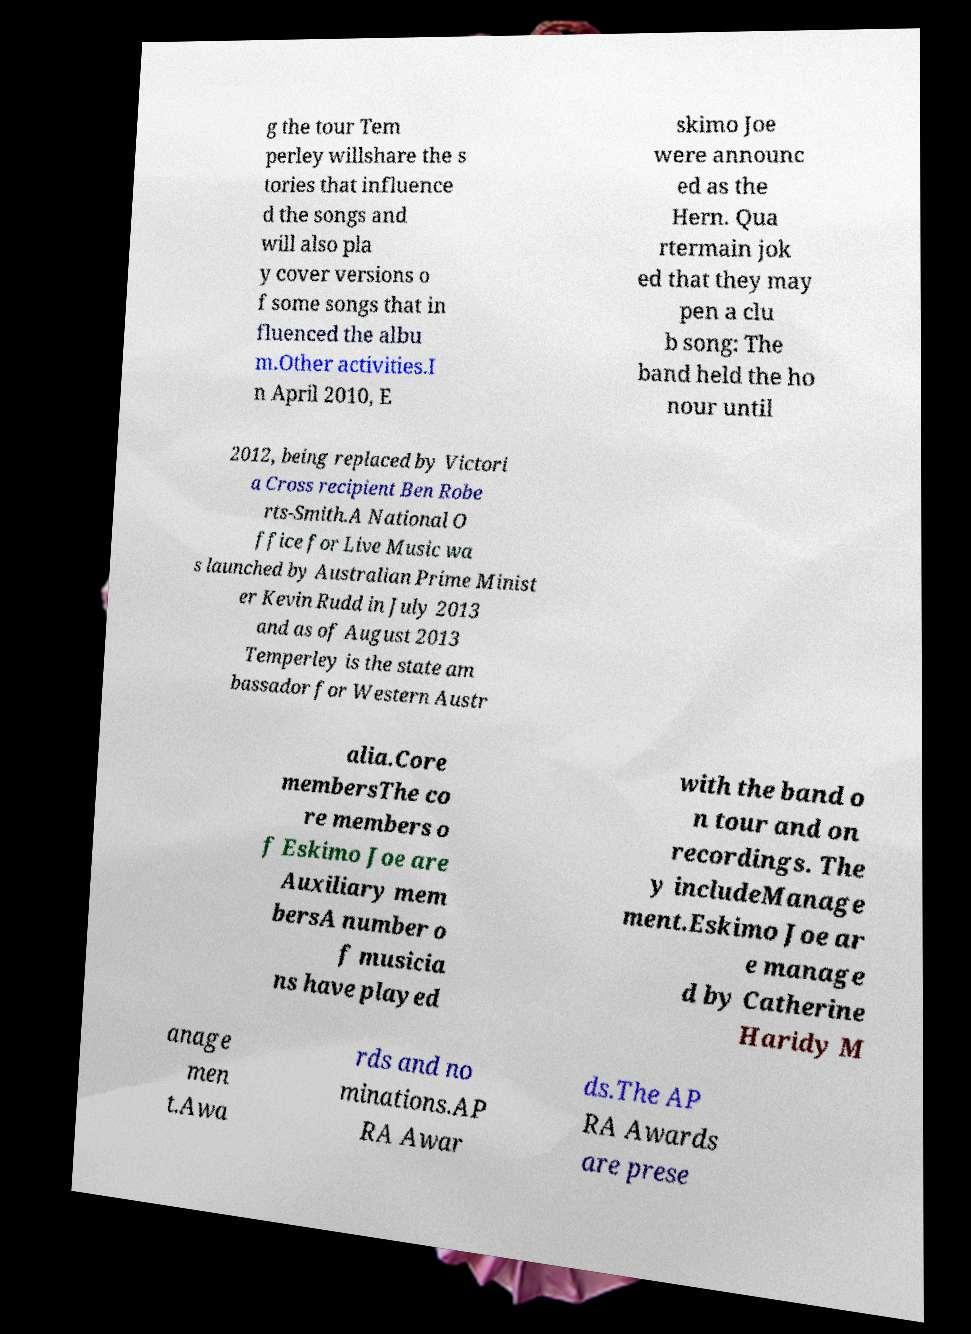Could you assist in decoding the text presented in this image and type it out clearly? g the tour Tem perley willshare the s tories that influence d the songs and will also pla y cover versions o f some songs that in fluenced the albu m.Other activities.I n April 2010, E skimo Joe were announc ed as the Hern. Qua rtermain jok ed that they may pen a clu b song: The band held the ho nour until 2012, being replaced by Victori a Cross recipient Ben Robe rts-Smith.A National O ffice for Live Music wa s launched by Australian Prime Minist er Kevin Rudd in July 2013 and as of August 2013 Temperley is the state am bassador for Western Austr alia.Core membersThe co re members o f Eskimo Joe are Auxiliary mem bersA number o f musicia ns have played with the band o n tour and on recordings. The y includeManage ment.Eskimo Joe ar e manage d by Catherine Haridy M anage men t.Awa rds and no minations.AP RA Awar ds.The AP RA Awards are prese 